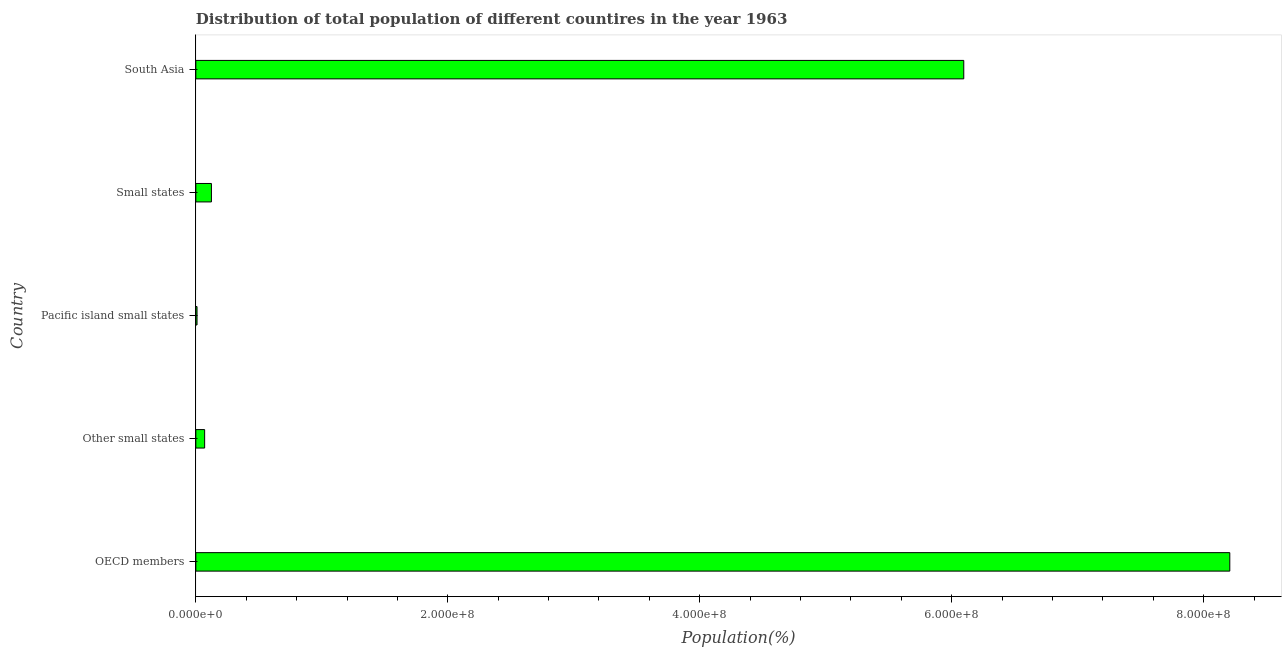Does the graph contain any zero values?
Give a very brief answer. No. What is the title of the graph?
Give a very brief answer. Distribution of total population of different countires in the year 1963. What is the label or title of the X-axis?
Your answer should be compact. Population(%). What is the population in Pacific island small states?
Offer a very short reply. 9.50e+05. Across all countries, what is the maximum population?
Provide a short and direct response. 8.21e+08. Across all countries, what is the minimum population?
Offer a terse response. 9.50e+05. In which country was the population maximum?
Make the answer very short. OECD members. In which country was the population minimum?
Offer a very short reply. Pacific island small states. What is the sum of the population?
Make the answer very short. 1.45e+09. What is the difference between the population in Other small states and Small states?
Make the answer very short. -5.39e+06. What is the average population per country?
Keep it short and to the point. 2.90e+08. What is the median population?
Your response must be concise. 1.24e+07. What is the ratio of the population in Other small states to that in South Asia?
Your answer should be compact. 0.01. What is the difference between the highest and the second highest population?
Keep it short and to the point. 2.11e+08. What is the difference between the highest and the lowest population?
Provide a succinct answer. 8.20e+08. In how many countries, is the population greater than the average population taken over all countries?
Keep it short and to the point. 2. How many countries are there in the graph?
Keep it short and to the point. 5. What is the Population(%) in OECD members?
Ensure brevity in your answer.  8.21e+08. What is the Population(%) in Other small states?
Give a very brief answer. 6.99e+06. What is the Population(%) in Pacific island small states?
Your answer should be compact. 9.50e+05. What is the Population(%) in Small states?
Your answer should be compact. 1.24e+07. What is the Population(%) of South Asia?
Offer a very short reply. 6.10e+08. What is the difference between the Population(%) in OECD members and Other small states?
Your answer should be very brief. 8.14e+08. What is the difference between the Population(%) in OECD members and Pacific island small states?
Your answer should be compact. 8.20e+08. What is the difference between the Population(%) in OECD members and Small states?
Provide a short and direct response. 8.08e+08. What is the difference between the Population(%) in OECD members and South Asia?
Offer a terse response. 2.11e+08. What is the difference between the Population(%) in Other small states and Pacific island small states?
Make the answer very short. 6.04e+06. What is the difference between the Population(%) in Other small states and Small states?
Your answer should be compact. -5.39e+06. What is the difference between the Population(%) in Other small states and South Asia?
Keep it short and to the point. -6.03e+08. What is the difference between the Population(%) in Pacific island small states and Small states?
Give a very brief answer. -1.14e+07. What is the difference between the Population(%) in Pacific island small states and South Asia?
Your answer should be compact. -6.09e+08. What is the difference between the Population(%) in Small states and South Asia?
Ensure brevity in your answer.  -5.97e+08. What is the ratio of the Population(%) in OECD members to that in Other small states?
Your answer should be compact. 117.44. What is the ratio of the Population(%) in OECD members to that in Pacific island small states?
Your response must be concise. 864.04. What is the ratio of the Population(%) in OECD members to that in Small states?
Ensure brevity in your answer.  66.33. What is the ratio of the Population(%) in OECD members to that in South Asia?
Offer a terse response. 1.35. What is the ratio of the Population(%) in Other small states to that in Pacific island small states?
Offer a terse response. 7.36. What is the ratio of the Population(%) in Other small states to that in Small states?
Your answer should be very brief. 0.56. What is the ratio of the Population(%) in Other small states to that in South Asia?
Your response must be concise. 0.01. What is the ratio of the Population(%) in Pacific island small states to that in Small states?
Your answer should be compact. 0.08. What is the ratio of the Population(%) in Pacific island small states to that in South Asia?
Keep it short and to the point. 0. What is the ratio of the Population(%) in Small states to that in South Asia?
Your response must be concise. 0.02. 